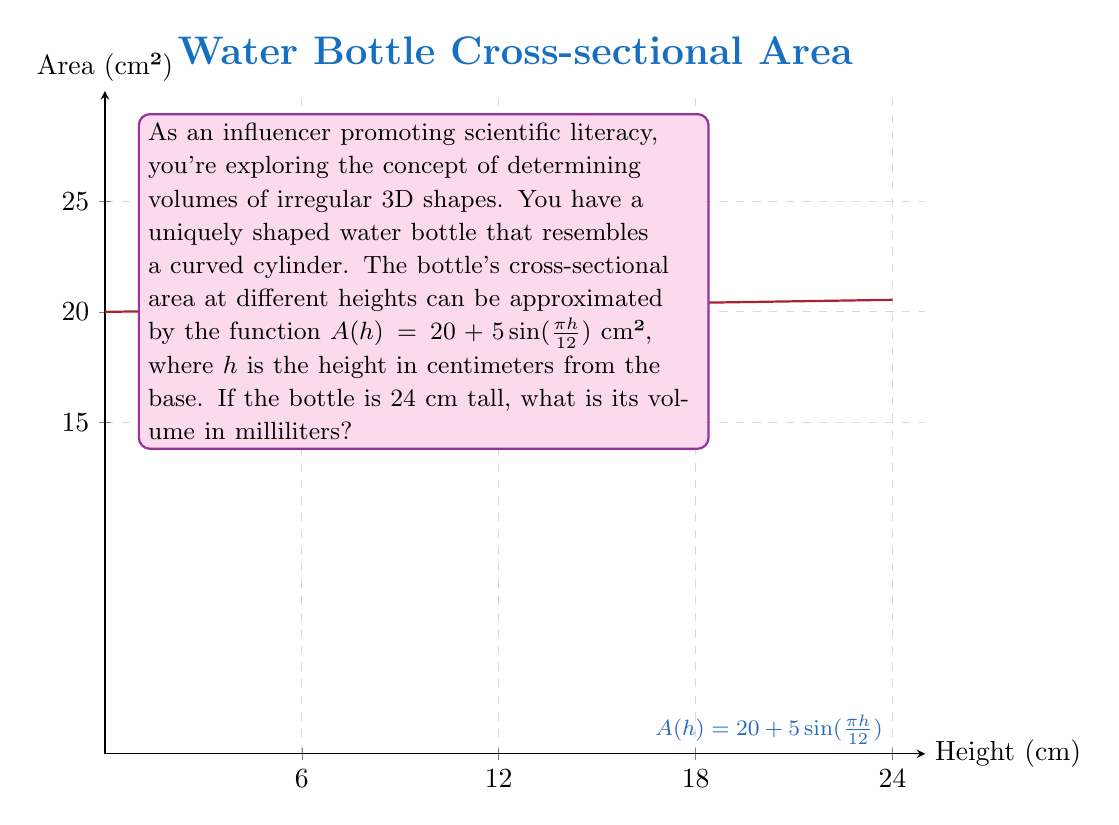Help me with this question. To find the volume of this irregular 3D shape, we need to use the concept of integration, as the cross-sectional area varies with height. Here's how we solve it step-by-step:

1) The volume of a solid with variable cross-sectional area is given by the integral:

   $$V = \int_0^h A(h) \, dh$$

   where $A(h)$ is the cross-sectional area function and $h$ is the height.

2) In this case, $A(h) = 20 + 5\sin(\frac{\pi h}{12})$ and the height is 24 cm.

3) Set up the integral:

   $$V = \int_0^{24} (20 + 5\sin(\frac{\pi h}{12})) \, dh$$

4) Integrate:
   $$V = [20h - \frac{60}{\pi}\cos(\frac{\pi h}{12})]_0^{24}$$

5) Evaluate the integral:
   $$V = (20 \cdot 24 - \frac{60}{\pi}\cos(2\pi)) - (0 - \frac{60}{\pi}\cos(0))$$
   $$V = 480 - \frac{60}{\pi}\cos(2\pi) + \frac{60}{\pi}$$
   $$V = 480 + \frac{60}{\pi}(1 - \cos(2\pi))$$
   $$V = 480 \text{ cm}^3$$ (since $\cos(2\pi) = 1$)

6) Convert cubic centimeters to milliliters:
   $$V = 480 \text{ mL}$$ (since 1 cm³ = 1 mL)
Answer: 480 mL 